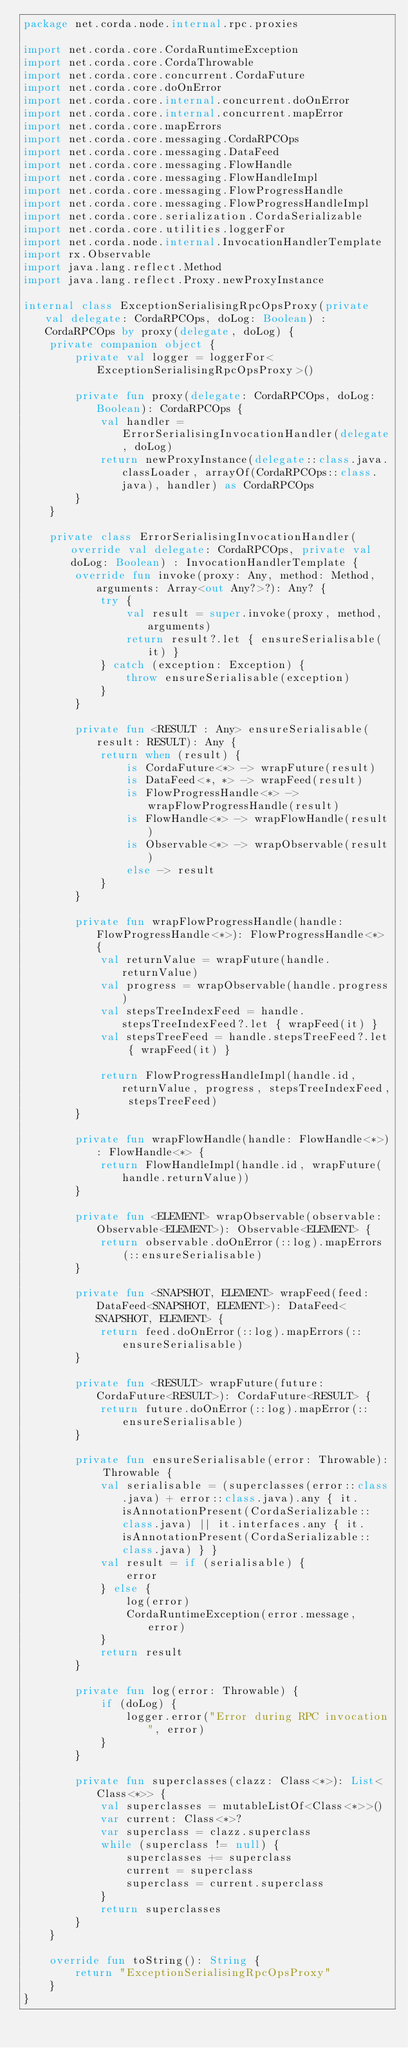<code> <loc_0><loc_0><loc_500><loc_500><_Kotlin_>package net.corda.node.internal.rpc.proxies

import net.corda.core.CordaRuntimeException
import net.corda.core.CordaThrowable
import net.corda.core.concurrent.CordaFuture
import net.corda.core.doOnError
import net.corda.core.internal.concurrent.doOnError
import net.corda.core.internal.concurrent.mapError
import net.corda.core.mapErrors
import net.corda.core.messaging.CordaRPCOps
import net.corda.core.messaging.DataFeed
import net.corda.core.messaging.FlowHandle
import net.corda.core.messaging.FlowHandleImpl
import net.corda.core.messaging.FlowProgressHandle
import net.corda.core.messaging.FlowProgressHandleImpl
import net.corda.core.serialization.CordaSerializable
import net.corda.core.utilities.loggerFor
import net.corda.node.internal.InvocationHandlerTemplate
import rx.Observable
import java.lang.reflect.Method
import java.lang.reflect.Proxy.newProxyInstance

internal class ExceptionSerialisingRpcOpsProxy(private val delegate: CordaRPCOps, doLog: Boolean) : CordaRPCOps by proxy(delegate, doLog) {
    private companion object {
        private val logger = loggerFor<ExceptionSerialisingRpcOpsProxy>()

        private fun proxy(delegate: CordaRPCOps, doLog: Boolean): CordaRPCOps {
            val handler = ErrorSerialisingInvocationHandler(delegate, doLog)
            return newProxyInstance(delegate::class.java.classLoader, arrayOf(CordaRPCOps::class.java), handler) as CordaRPCOps
        }
    }

    private class ErrorSerialisingInvocationHandler(override val delegate: CordaRPCOps, private val doLog: Boolean) : InvocationHandlerTemplate {
        override fun invoke(proxy: Any, method: Method, arguments: Array<out Any?>?): Any? {
            try {
                val result = super.invoke(proxy, method, arguments)
                return result?.let { ensureSerialisable(it) }
            } catch (exception: Exception) {
                throw ensureSerialisable(exception)
            }
        }

        private fun <RESULT : Any> ensureSerialisable(result: RESULT): Any {
            return when (result) {
                is CordaFuture<*> -> wrapFuture(result)
                is DataFeed<*, *> -> wrapFeed(result)
                is FlowProgressHandle<*> -> wrapFlowProgressHandle(result)
                is FlowHandle<*> -> wrapFlowHandle(result)
                is Observable<*> -> wrapObservable(result)
                else -> result
            }
        }

        private fun wrapFlowProgressHandle(handle: FlowProgressHandle<*>): FlowProgressHandle<*> {
            val returnValue = wrapFuture(handle.returnValue)
            val progress = wrapObservable(handle.progress)
            val stepsTreeIndexFeed = handle.stepsTreeIndexFeed?.let { wrapFeed(it) }
            val stepsTreeFeed = handle.stepsTreeFeed?.let { wrapFeed(it) }

            return FlowProgressHandleImpl(handle.id, returnValue, progress, stepsTreeIndexFeed, stepsTreeFeed)
        }

        private fun wrapFlowHandle(handle: FlowHandle<*>): FlowHandle<*> {
            return FlowHandleImpl(handle.id, wrapFuture(handle.returnValue))
        }

        private fun <ELEMENT> wrapObservable(observable: Observable<ELEMENT>): Observable<ELEMENT> {
            return observable.doOnError(::log).mapErrors(::ensureSerialisable)
        }

        private fun <SNAPSHOT, ELEMENT> wrapFeed(feed: DataFeed<SNAPSHOT, ELEMENT>): DataFeed<SNAPSHOT, ELEMENT> {
            return feed.doOnError(::log).mapErrors(::ensureSerialisable)
        }

        private fun <RESULT> wrapFuture(future: CordaFuture<RESULT>): CordaFuture<RESULT> {
            return future.doOnError(::log).mapError(::ensureSerialisable)
        }

        private fun ensureSerialisable(error: Throwable): Throwable {
            val serialisable = (superclasses(error::class.java) + error::class.java).any { it.isAnnotationPresent(CordaSerializable::class.java) || it.interfaces.any { it.isAnnotationPresent(CordaSerializable::class.java) } }
            val result = if (serialisable) {
                error
            } else {
                log(error)
                CordaRuntimeException(error.message, error)
            }
            return result
        }

        private fun log(error: Throwable) {
            if (doLog) {
                logger.error("Error during RPC invocation", error)
            }
        }

        private fun superclasses(clazz: Class<*>): List<Class<*>> {
            val superclasses = mutableListOf<Class<*>>()
            var current: Class<*>?
            var superclass = clazz.superclass
            while (superclass != null) {
                superclasses += superclass
                current = superclass
                superclass = current.superclass
            }
            return superclasses
        }
    }

    override fun toString(): String {
        return "ExceptionSerialisingRpcOpsProxy"
    }
}</code> 